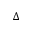Convert formula to latex. <formula><loc_0><loc_0><loc_500><loc_500>\Delta</formula> 